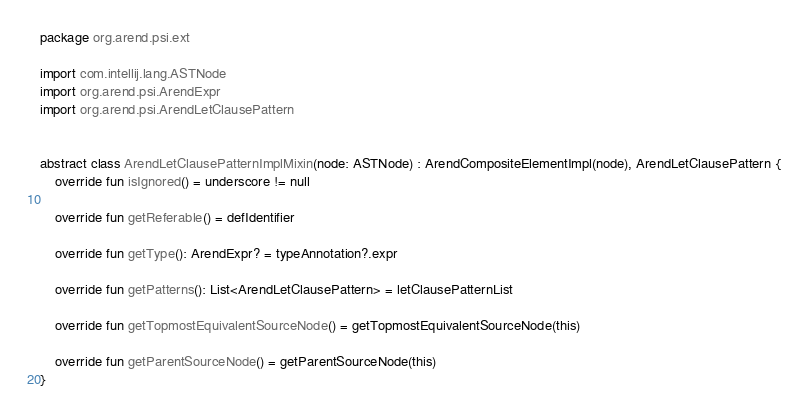Convert code to text. <code><loc_0><loc_0><loc_500><loc_500><_Kotlin_>package org.arend.psi.ext

import com.intellij.lang.ASTNode
import org.arend.psi.ArendExpr
import org.arend.psi.ArendLetClausePattern


abstract class ArendLetClausePatternImplMixin(node: ASTNode) : ArendCompositeElementImpl(node), ArendLetClausePattern {
    override fun isIgnored() = underscore != null

    override fun getReferable() = defIdentifier

    override fun getType(): ArendExpr? = typeAnnotation?.expr

    override fun getPatterns(): List<ArendLetClausePattern> = letClausePatternList

    override fun getTopmostEquivalentSourceNode() = getTopmostEquivalentSourceNode(this)

    override fun getParentSourceNode() = getParentSourceNode(this)
}</code> 